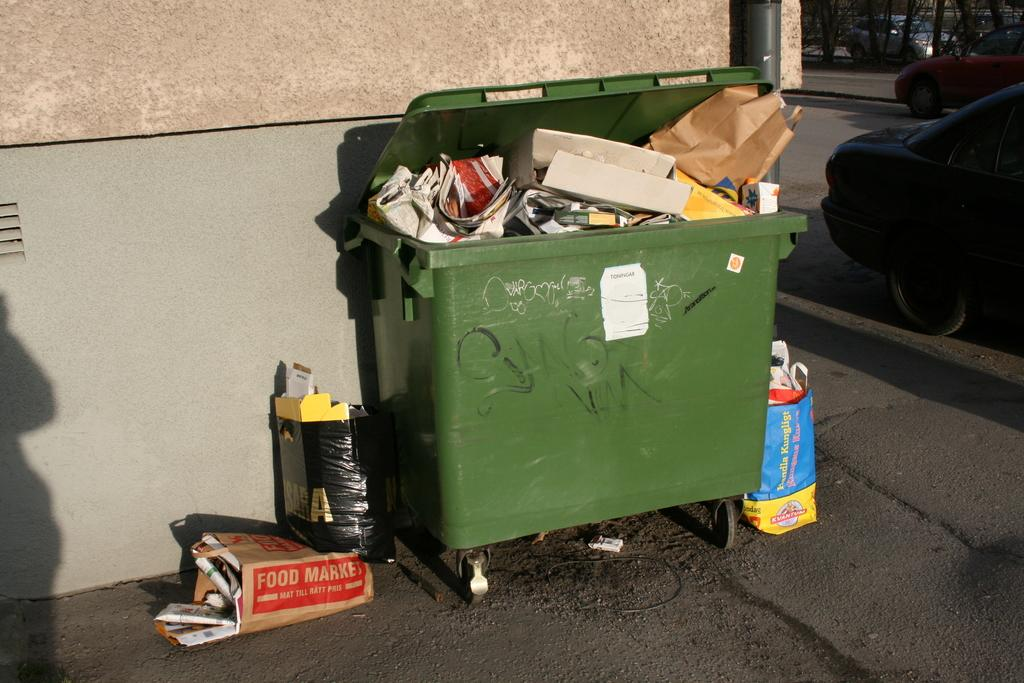<image>
Provide a brief description of the given image. A brown paper bag from the food market lays on the ground near a green dumpster. 